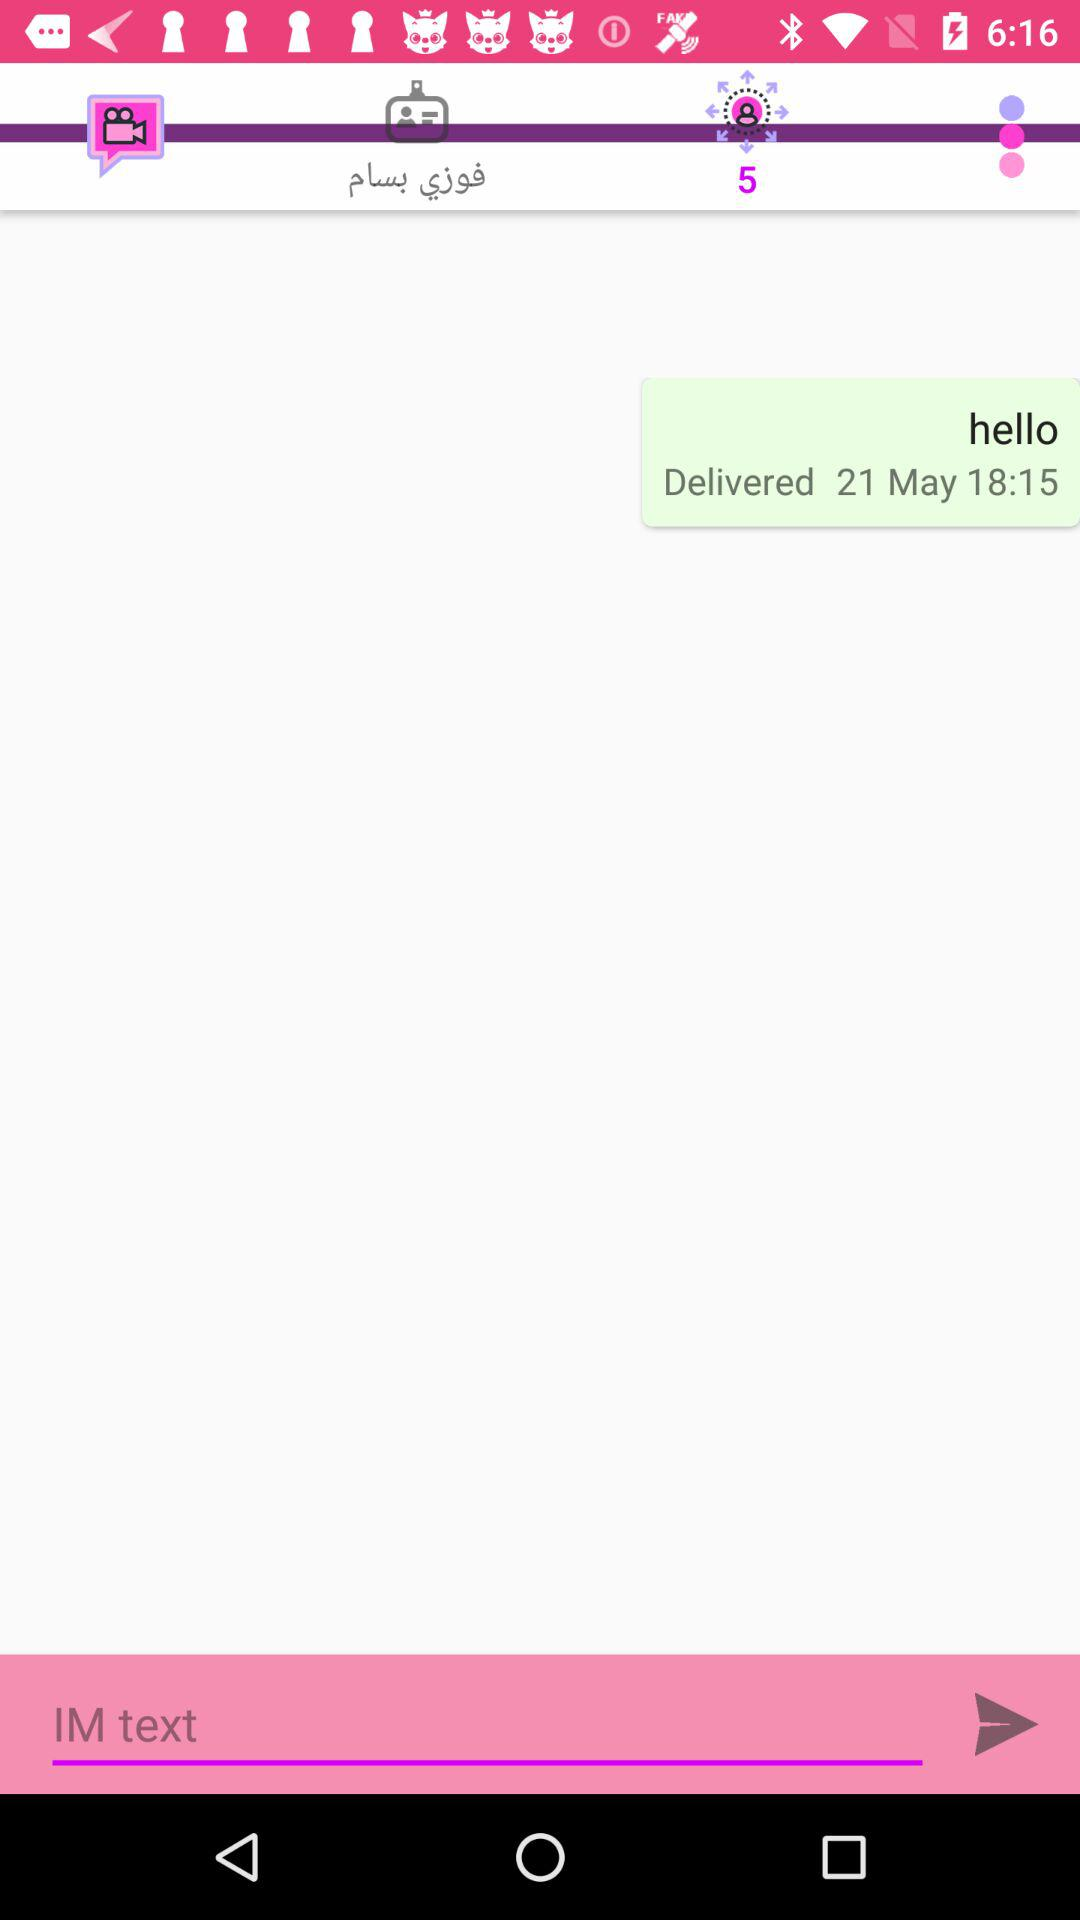How many more unread messages are there than read messages?
Answer the question using a single word or phrase. 4 